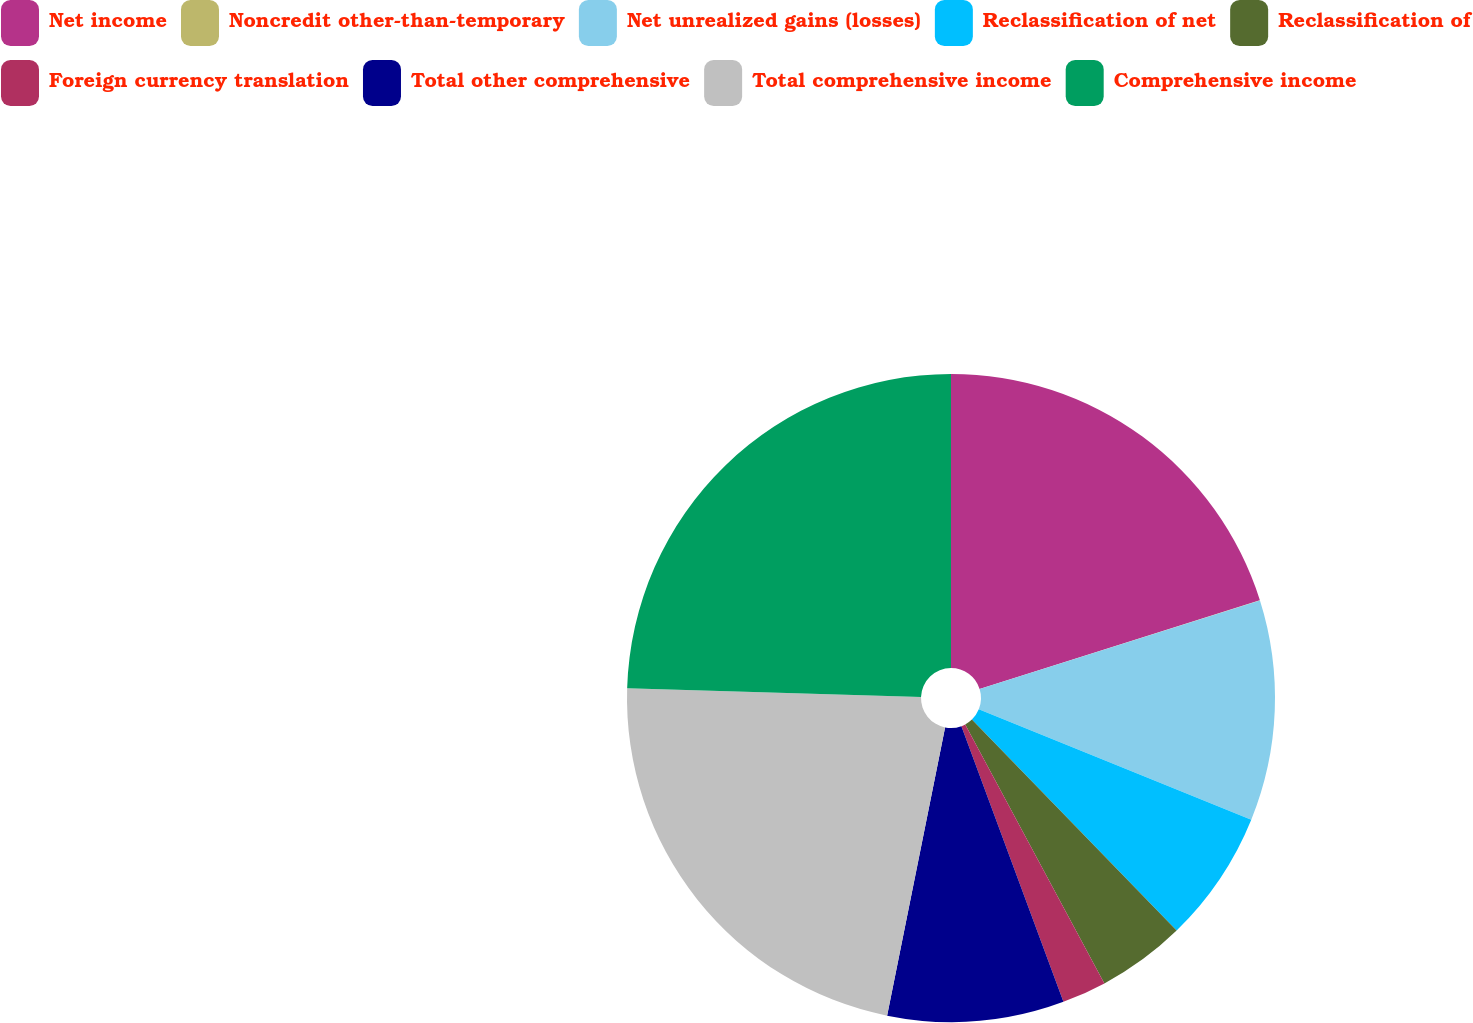<chart> <loc_0><loc_0><loc_500><loc_500><pie_chart><fcel>Net income<fcel>Noncredit other-than-temporary<fcel>Net unrealized gains (losses)<fcel>Reclassification of net<fcel>Reclassification of<fcel>Foreign currency translation<fcel>Total other comprehensive<fcel>Total comprehensive income<fcel>Comprehensive income<nl><fcel>20.12%<fcel>0.01%<fcel>11.0%<fcel>6.61%<fcel>4.41%<fcel>2.21%<fcel>8.8%<fcel>22.32%<fcel>24.52%<nl></chart> 